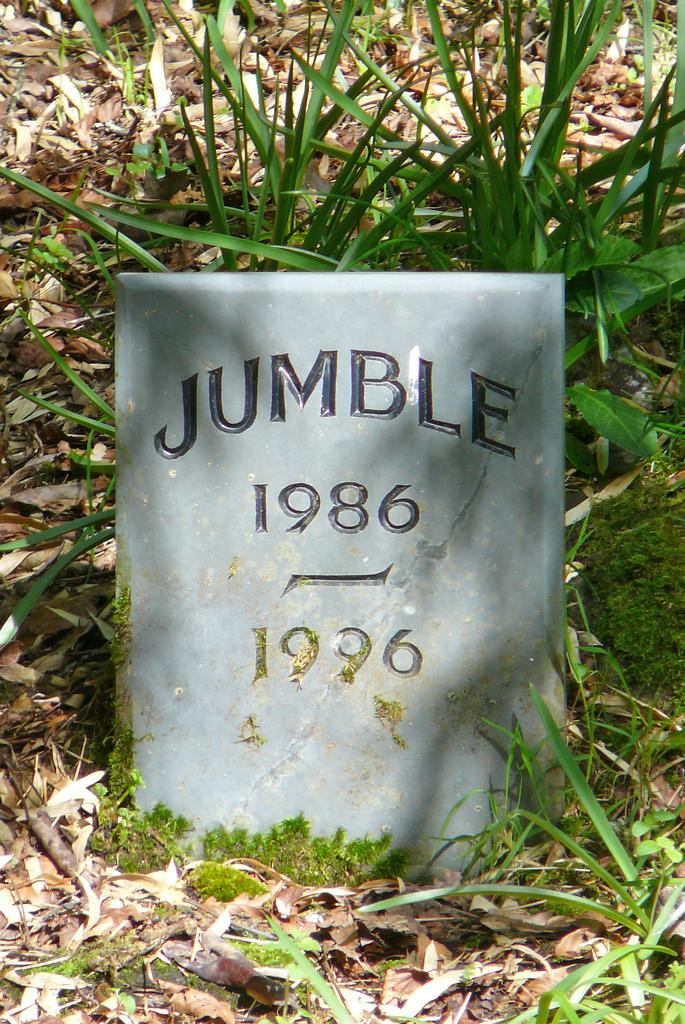What is the main object on the ground in the image? There is a stone plate with text in the image. Where is the stone plate located? The stone plate is on the ground. What else can be seen on the ground in the image? Leaves are visible on the ground. What type of vegetation is present in the image? Plants are present in the image. What type of advertisement is displayed on the stone plate in the image? There is no advertisement present on the stone plate in the image; it contains text, but not an advertisement. 